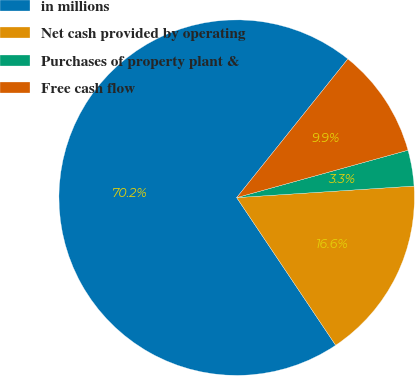Convert chart to OTSL. <chart><loc_0><loc_0><loc_500><loc_500><pie_chart><fcel>in millions<fcel>Net cash provided by operating<fcel>Purchases of property plant &<fcel>Free cash flow<nl><fcel>70.16%<fcel>16.64%<fcel>3.26%<fcel>9.95%<nl></chart> 